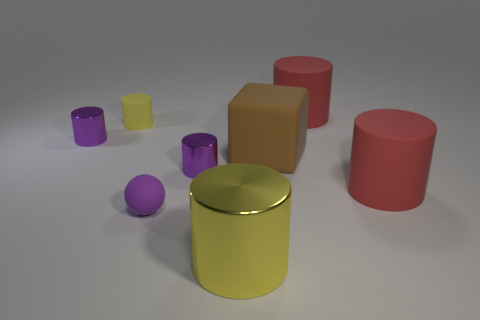Subtract 1 cylinders. How many cylinders are left? 5 Subtract all purple shiny cylinders. How many cylinders are left? 4 Subtract all cyan cylinders. Subtract all yellow balls. How many cylinders are left? 6 Add 2 large brown blocks. How many objects exist? 10 Subtract all cubes. How many objects are left? 7 Subtract 1 purple spheres. How many objects are left? 7 Subtract all big yellow metal things. Subtract all large cubes. How many objects are left? 6 Add 4 yellow rubber objects. How many yellow rubber objects are left? 5 Add 5 spheres. How many spheres exist? 6 